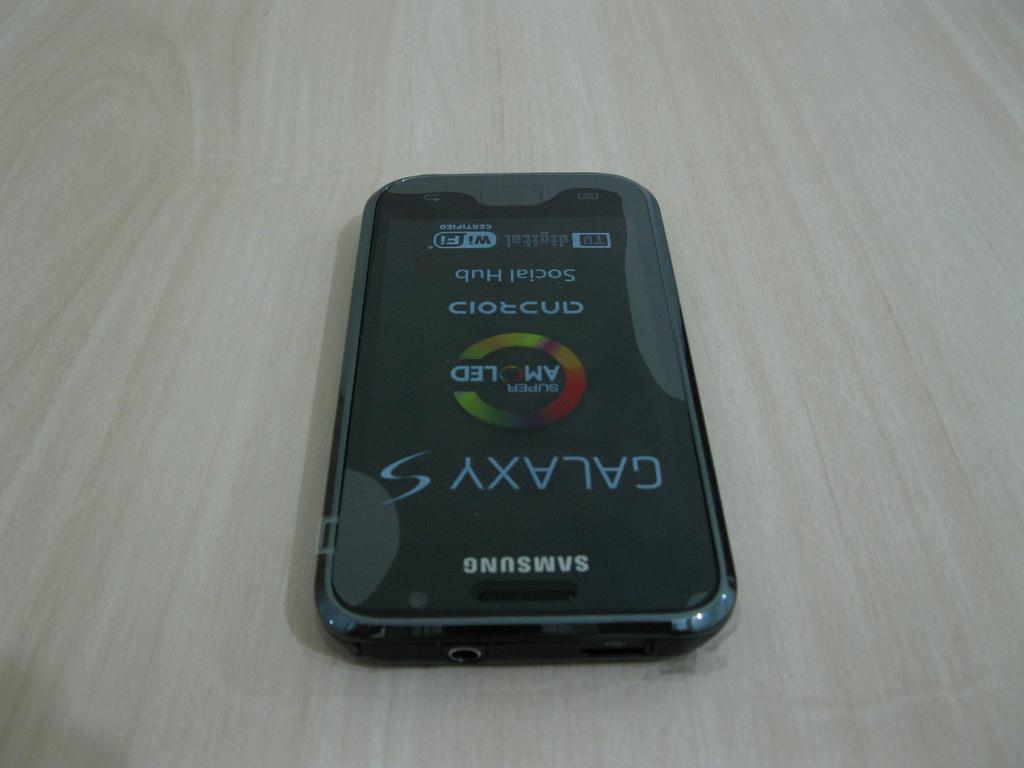Provide a one-sentence caption for the provided image. A samsung Galaxy S displaying the Android Social Hub and AMOLED technology screen. 